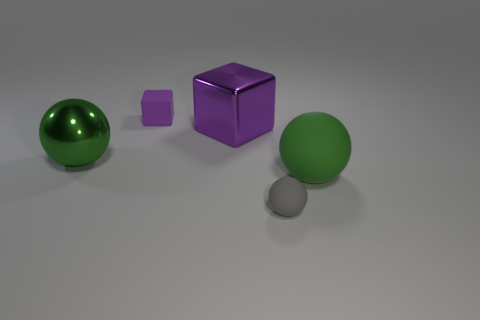What is the material of the small thing that is the same color as the metal cube?
Provide a succinct answer. Rubber. There is a gray thing that is the same size as the purple matte block; what shape is it?
Offer a very short reply. Sphere. What number of other things are the same color as the shiny ball?
Offer a terse response. 1. There is a green object that is in front of the green thing that is to the left of the large green rubber thing; what is its size?
Keep it short and to the point. Large. Is the large green ball on the left side of the gray ball made of the same material as the large purple cube?
Make the answer very short. Yes. There is a large green object to the right of the tiny block; what is its shape?
Ensure brevity in your answer.  Sphere. What number of green things have the same size as the purple metallic cube?
Your response must be concise. 2. What is the size of the green metal ball?
Give a very brief answer. Large. How many big shiny things are in front of the green metallic sphere?
Provide a succinct answer. 0. There is a big green thing that is the same material as the small sphere; what shape is it?
Your response must be concise. Sphere. 